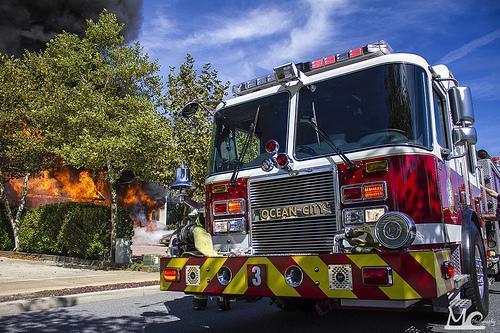How many fire trucks are there?
Give a very brief answer. 1. 